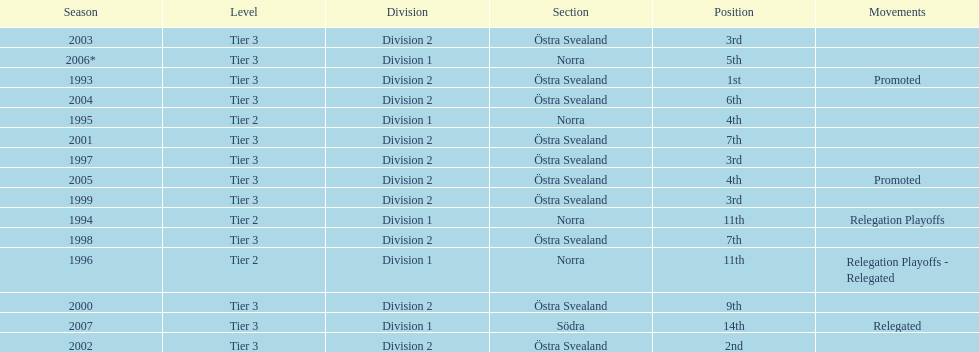What year is at least on the list? 2007. 